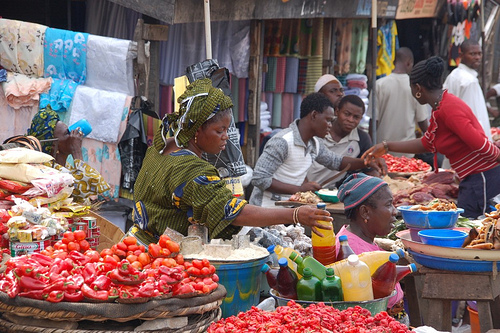<image>
Is the hat on the woman? No. The hat is not positioned on the woman. They may be near each other, but the hat is not supported by or resting on top of the woman. Is there a woman in front of the drink? No. The woman is not in front of the drink. The spatial positioning shows a different relationship between these objects. 